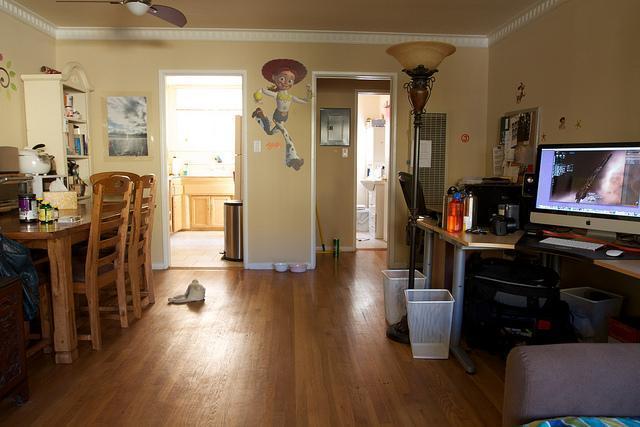How many chairs are there?
Give a very brief answer. 2. 